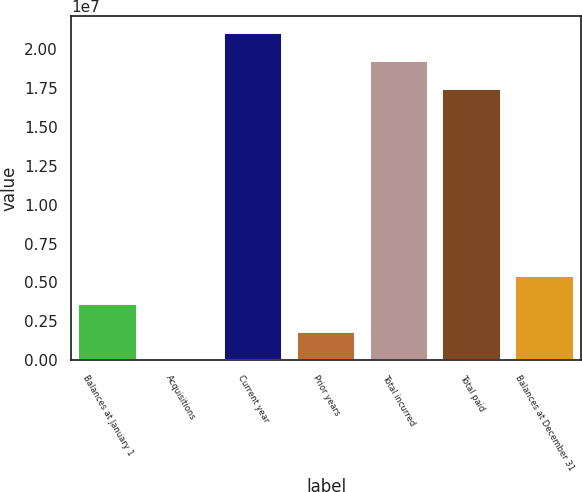<chart> <loc_0><loc_0><loc_500><loc_500><bar_chart><fcel>Balances at January 1<fcel>Acquisitions<fcel>Current year<fcel>Prior years<fcel>Total incurred<fcel>Total paid<fcel>Balances at December 31<nl><fcel>3.63587e+06<fcel>41029<fcel>2.10325e+07<fcel>1.83845e+06<fcel>1.9235e+07<fcel>1.74376e+07<fcel>5.43329e+06<nl></chart> 